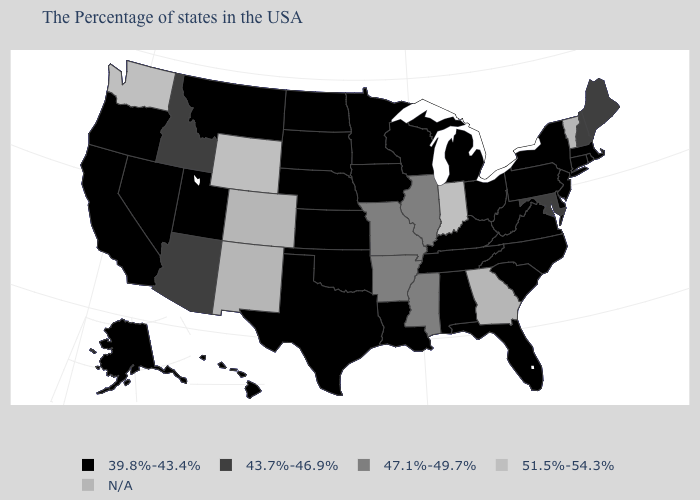Is the legend a continuous bar?
Concise answer only. No. What is the value of Indiana?
Answer briefly. 51.5%-54.3%. What is the value of Alaska?
Short answer required. 39.8%-43.4%. Which states have the lowest value in the USA?
Give a very brief answer. Massachusetts, Rhode Island, Connecticut, New York, New Jersey, Delaware, Pennsylvania, Virginia, North Carolina, South Carolina, West Virginia, Ohio, Florida, Michigan, Kentucky, Alabama, Tennessee, Wisconsin, Louisiana, Minnesota, Iowa, Kansas, Nebraska, Oklahoma, Texas, South Dakota, North Dakota, Utah, Montana, Nevada, California, Oregon, Alaska, Hawaii. Name the states that have a value in the range 39.8%-43.4%?
Short answer required. Massachusetts, Rhode Island, Connecticut, New York, New Jersey, Delaware, Pennsylvania, Virginia, North Carolina, South Carolina, West Virginia, Ohio, Florida, Michigan, Kentucky, Alabama, Tennessee, Wisconsin, Louisiana, Minnesota, Iowa, Kansas, Nebraska, Oklahoma, Texas, South Dakota, North Dakota, Utah, Montana, Nevada, California, Oregon, Alaska, Hawaii. Name the states that have a value in the range 47.1%-49.7%?
Short answer required. Illinois, Mississippi, Missouri, Arkansas. Name the states that have a value in the range 51.5%-54.3%?
Answer briefly. Indiana, Wyoming, Washington. What is the lowest value in the South?
Give a very brief answer. 39.8%-43.4%. Which states have the highest value in the USA?
Short answer required. Indiana, Wyoming, Washington. Name the states that have a value in the range 39.8%-43.4%?
Be succinct. Massachusetts, Rhode Island, Connecticut, New York, New Jersey, Delaware, Pennsylvania, Virginia, North Carolina, South Carolina, West Virginia, Ohio, Florida, Michigan, Kentucky, Alabama, Tennessee, Wisconsin, Louisiana, Minnesota, Iowa, Kansas, Nebraska, Oklahoma, Texas, South Dakota, North Dakota, Utah, Montana, Nevada, California, Oregon, Alaska, Hawaii. Name the states that have a value in the range 39.8%-43.4%?
Give a very brief answer. Massachusetts, Rhode Island, Connecticut, New York, New Jersey, Delaware, Pennsylvania, Virginia, North Carolina, South Carolina, West Virginia, Ohio, Florida, Michigan, Kentucky, Alabama, Tennessee, Wisconsin, Louisiana, Minnesota, Iowa, Kansas, Nebraska, Oklahoma, Texas, South Dakota, North Dakota, Utah, Montana, Nevada, California, Oregon, Alaska, Hawaii. Does Mississippi have the lowest value in the South?
Answer briefly. No. What is the highest value in states that border Georgia?
Keep it brief. 39.8%-43.4%. What is the highest value in states that border Montana?
Concise answer only. 51.5%-54.3%. Among the states that border Alabama , which have the lowest value?
Answer briefly. Florida, Tennessee. 